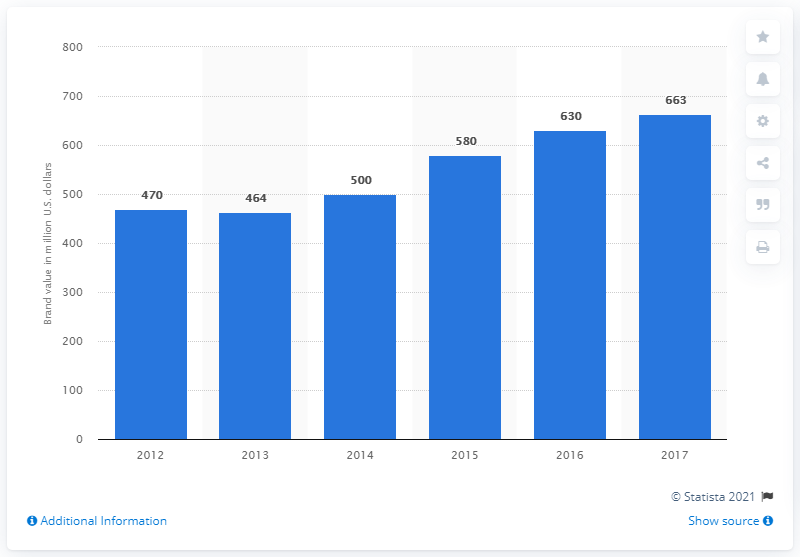Give some essential details in this illustration. In 2017, the brand value of the Super Bowl was 663. 